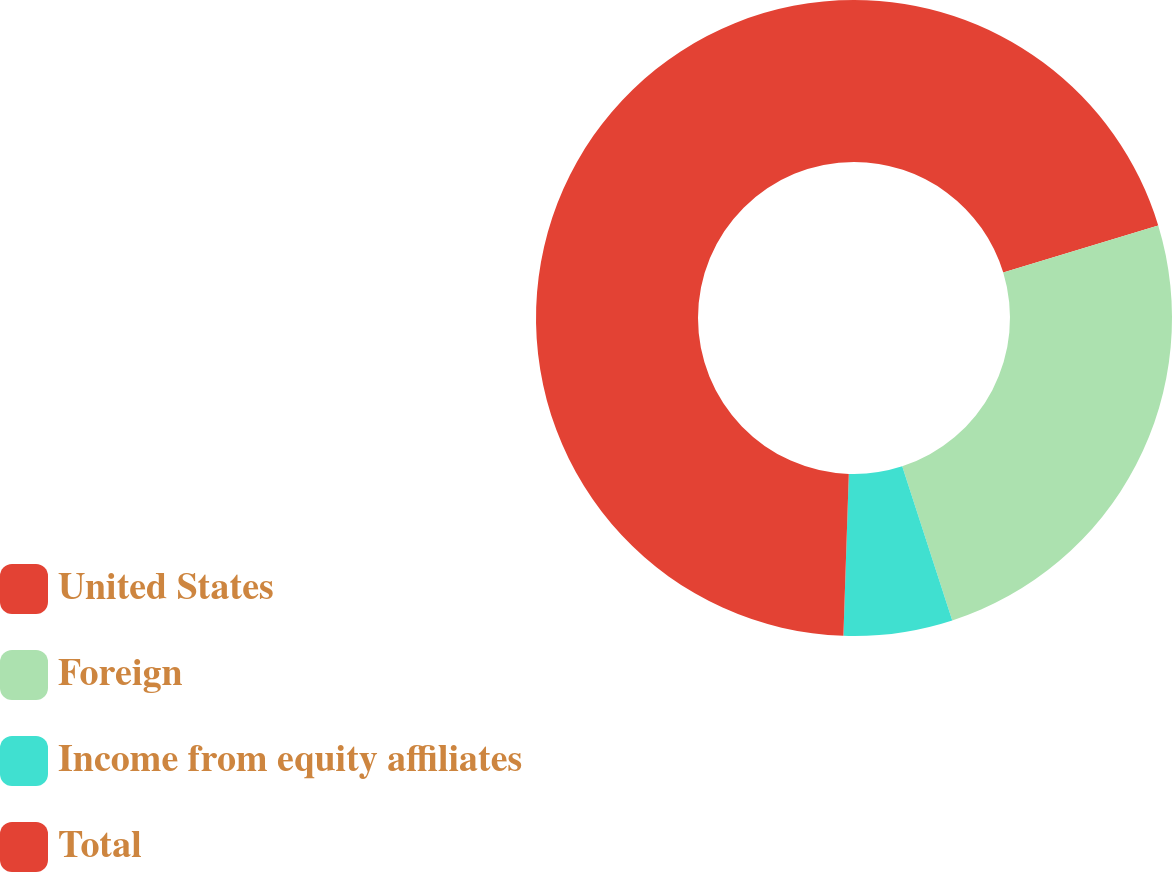<chart> <loc_0><loc_0><loc_500><loc_500><pie_chart><fcel>United States<fcel>Foreign<fcel>Income from equity affiliates<fcel>Total<nl><fcel>20.3%<fcel>24.7%<fcel>5.53%<fcel>49.47%<nl></chart> 